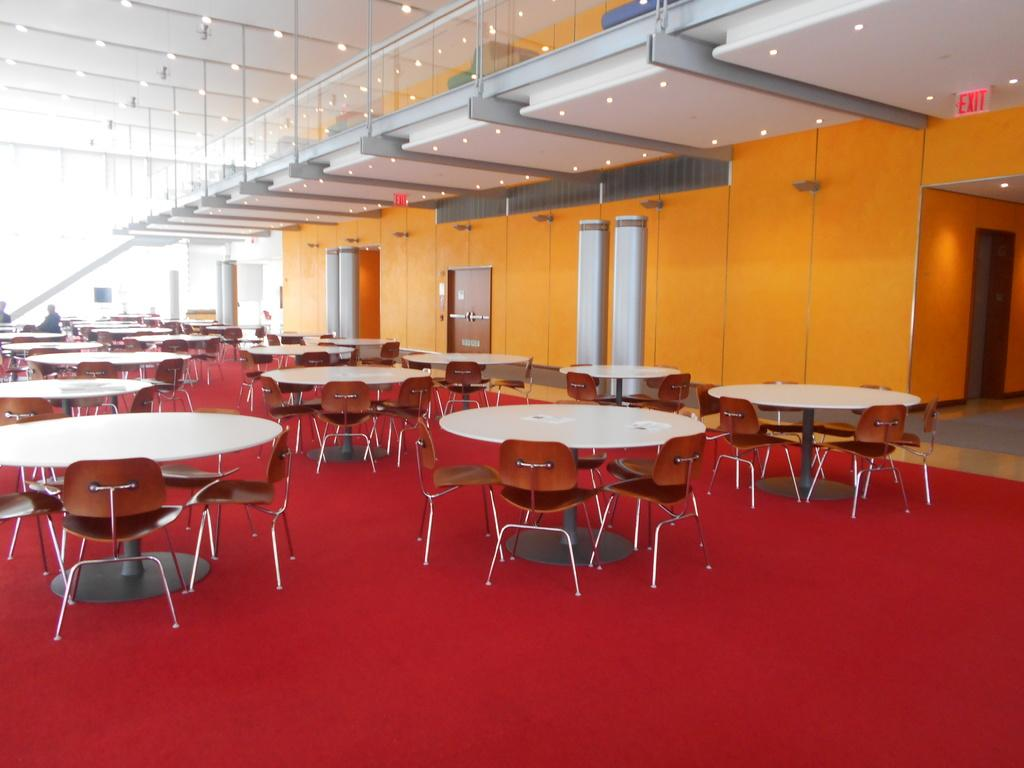What type of furniture can be seen in the image? There are tables and chairs in the image. What is the color of the floor in the image? The floor has a red color. What is the color of the wall in the image? The wall has an orange color. What type of barrier is present in the image? There is a glass railing in the image. What type of illumination is present in the image? There are lights in the image. What emotion is the glass railing expressing in the image? The glass railing does not express emotions; it is an inanimate object. 